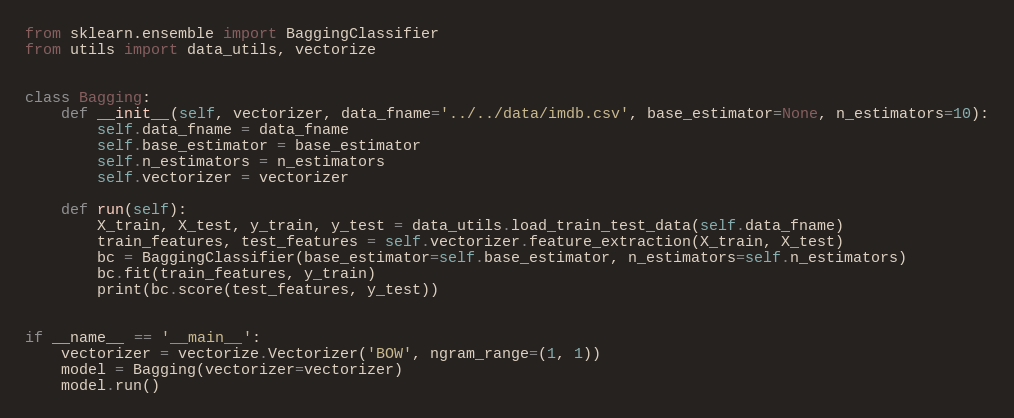Convert code to text. <code><loc_0><loc_0><loc_500><loc_500><_Python_>from sklearn.ensemble import BaggingClassifier
from utils import data_utils, vectorize


class Bagging:
    def __init__(self, vectorizer, data_fname='../../data/imdb.csv', base_estimator=None, n_estimators=10):
        self.data_fname = data_fname
        self.base_estimator = base_estimator
        self.n_estimators = n_estimators
        self.vectorizer = vectorizer

    def run(self):
        X_train, X_test, y_train, y_test = data_utils.load_train_test_data(self.data_fname)
        train_features, test_features = self.vectorizer.feature_extraction(X_train, X_test)
        bc = BaggingClassifier(base_estimator=self.base_estimator, n_estimators=self.n_estimators)
        bc.fit(train_features, y_train)
        print(bc.score(test_features, y_test))


if __name__ == '__main__':
    vectorizer = vectorize.Vectorizer('BOW', ngram_range=(1, 1))
    model = Bagging(vectorizer=vectorizer)
    model.run()
</code> 